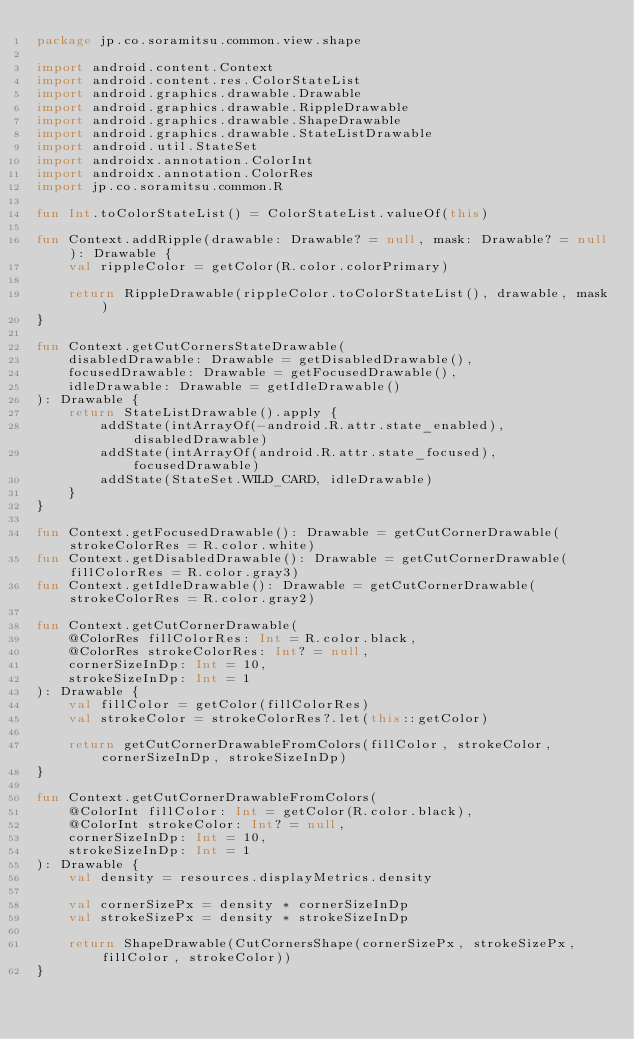Convert code to text. <code><loc_0><loc_0><loc_500><loc_500><_Kotlin_>package jp.co.soramitsu.common.view.shape

import android.content.Context
import android.content.res.ColorStateList
import android.graphics.drawable.Drawable
import android.graphics.drawable.RippleDrawable
import android.graphics.drawable.ShapeDrawable
import android.graphics.drawable.StateListDrawable
import android.util.StateSet
import androidx.annotation.ColorInt
import androidx.annotation.ColorRes
import jp.co.soramitsu.common.R

fun Int.toColorStateList() = ColorStateList.valueOf(this)

fun Context.addRipple(drawable: Drawable? = null, mask: Drawable? = null): Drawable {
    val rippleColor = getColor(R.color.colorPrimary)

    return RippleDrawable(rippleColor.toColorStateList(), drawable, mask)
}

fun Context.getCutCornersStateDrawable(
    disabledDrawable: Drawable = getDisabledDrawable(),
    focusedDrawable: Drawable = getFocusedDrawable(),
    idleDrawable: Drawable = getIdleDrawable()
): Drawable {
    return StateListDrawable().apply {
        addState(intArrayOf(-android.R.attr.state_enabled), disabledDrawable)
        addState(intArrayOf(android.R.attr.state_focused), focusedDrawable)
        addState(StateSet.WILD_CARD, idleDrawable)
    }
}

fun Context.getFocusedDrawable(): Drawable = getCutCornerDrawable(strokeColorRes = R.color.white)
fun Context.getDisabledDrawable(): Drawable = getCutCornerDrawable(fillColorRes = R.color.gray3)
fun Context.getIdleDrawable(): Drawable = getCutCornerDrawable(strokeColorRes = R.color.gray2)

fun Context.getCutCornerDrawable(
    @ColorRes fillColorRes: Int = R.color.black,
    @ColorRes strokeColorRes: Int? = null,
    cornerSizeInDp: Int = 10,
    strokeSizeInDp: Int = 1
): Drawable {
    val fillColor = getColor(fillColorRes)
    val strokeColor = strokeColorRes?.let(this::getColor)

    return getCutCornerDrawableFromColors(fillColor, strokeColor, cornerSizeInDp, strokeSizeInDp)
}

fun Context.getCutCornerDrawableFromColors(
    @ColorInt fillColor: Int = getColor(R.color.black),
    @ColorInt strokeColor: Int? = null,
    cornerSizeInDp: Int = 10,
    strokeSizeInDp: Int = 1
): Drawable {
    val density = resources.displayMetrics.density

    val cornerSizePx = density * cornerSizeInDp
    val strokeSizePx = density * strokeSizeInDp

    return ShapeDrawable(CutCornersShape(cornerSizePx, strokeSizePx, fillColor, strokeColor))
}</code> 